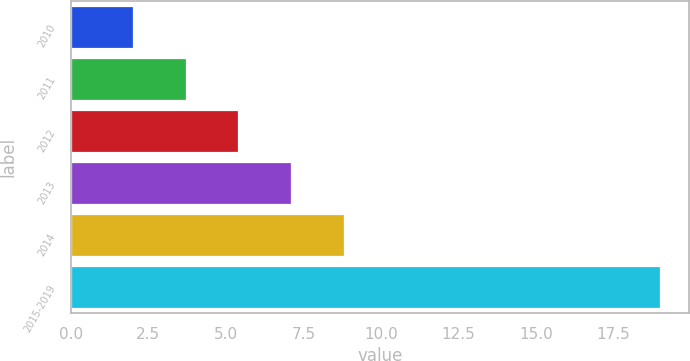Convert chart to OTSL. <chart><loc_0><loc_0><loc_500><loc_500><bar_chart><fcel>2010<fcel>2011<fcel>2012<fcel>2013<fcel>2014<fcel>2015-2019<nl><fcel>2<fcel>3.7<fcel>5.4<fcel>7.1<fcel>8.8<fcel>19<nl></chart> 